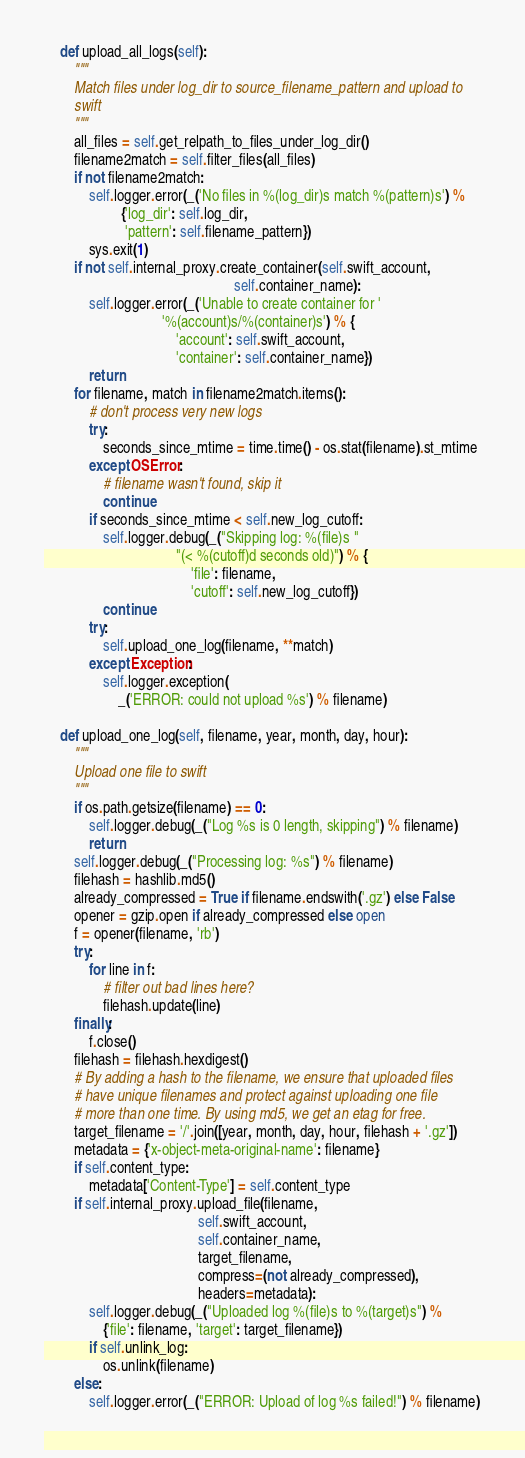Convert code to text. <code><loc_0><loc_0><loc_500><loc_500><_Python_>    def upload_all_logs(self):
        """
        Match files under log_dir to source_filename_pattern and upload to
        swift
        """
        all_files = self.get_relpath_to_files_under_log_dir()
        filename2match = self.filter_files(all_files)
        if not filename2match:
            self.logger.error(_('No files in %(log_dir)s match %(pattern)s') %
                     {'log_dir': self.log_dir,
                      'pattern': self.filename_pattern})
            sys.exit(1)
        if not self.internal_proxy.create_container(self.swift_account,
                                                    self.container_name):
            self.logger.error(_('Unable to create container for '
                                '%(account)s/%(container)s') % {
                                    'account': self.swift_account,
                                    'container': self.container_name})
            return
        for filename, match in filename2match.items():
            # don't process very new logs
            try:
                seconds_since_mtime = time.time() - os.stat(filename).st_mtime
            except OSError:
                # filename wasn't found, skip it
                continue
            if seconds_since_mtime < self.new_log_cutoff:
                self.logger.debug(_("Skipping log: %(file)s "
                                    "(< %(cutoff)d seconds old)") % {
                                        'file': filename,
                                        'cutoff': self.new_log_cutoff})
                continue
            try:
                self.upload_one_log(filename, **match)
            except Exception:
                self.logger.exception(
                    _('ERROR: could not upload %s') % filename)

    def upload_one_log(self, filename, year, month, day, hour):
        """
        Upload one file to swift
        """
        if os.path.getsize(filename) == 0:
            self.logger.debug(_("Log %s is 0 length, skipping") % filename)
            return
        self.logger.debug(_("Processing log: %s") % filename)
        filehash = hashlib.md5()
        already_compressed = True if filename.endswith('.gz') else False
        opener = gzip.open if already_compressed else open
        f = opener(filename, 'rb')
        try:
            for line in f:
                # filter out bad lines here?
                filehash.update(line)
        finally:
            f.close()
        filehash = filehash.hexdigest()
        # By adding a hash to the filename, we ensure that uploaded files
        # have unique filenames and protect against uploading one file
        # more than one time. By using md5, we get an etag for free.
        target_filename = '/'.join([year, month, day, hour, filehash + '.gz'])
        metadata = {'x-object-meta-original-name': filename}
        if self.content_type:
            metadata['Content-Type'] = self.content_type
        if self.internal_proxy.upload_file(filename,
                                          self.swift_account,
                                          self.container_name,
                                          target_filename,
                                          compress=(not already_compressed),
                                          headers=metadata):
            self.logger.debug(_("Uploaded log %(file)s to %(target)s") %
                {'file': filename, 'target': target_filename})
            if self.unlink_log:
                os.unlink(filename)
        else:
            self.logger.error(_("ERROR: Upload of log %s failed!") % filename)
</code> 